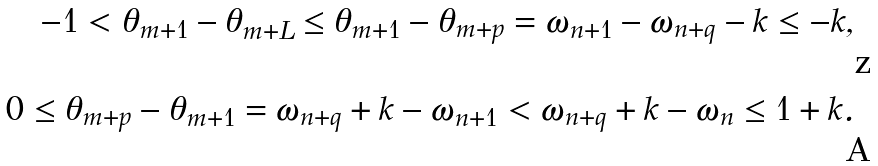<formula> <loc_0><loc_0><loc_500><loc_500>- 1 < \theta _ { m + 1 } - \theta _ { m + L } \leq \theta _ { m + 1 } - \theta _ { m + p } = \omega _ { n + 1 } - \omega _ { n + q } - k \leq - k , \\ 0 \leq \theta _ { m + p } - \theta _ { m + 1 } = \omega _ { n + q } + k - \omega _ { n + 1 } < \omega _ { n + q } + k - \omega _ { n } \leq 1 + k .</formula> 